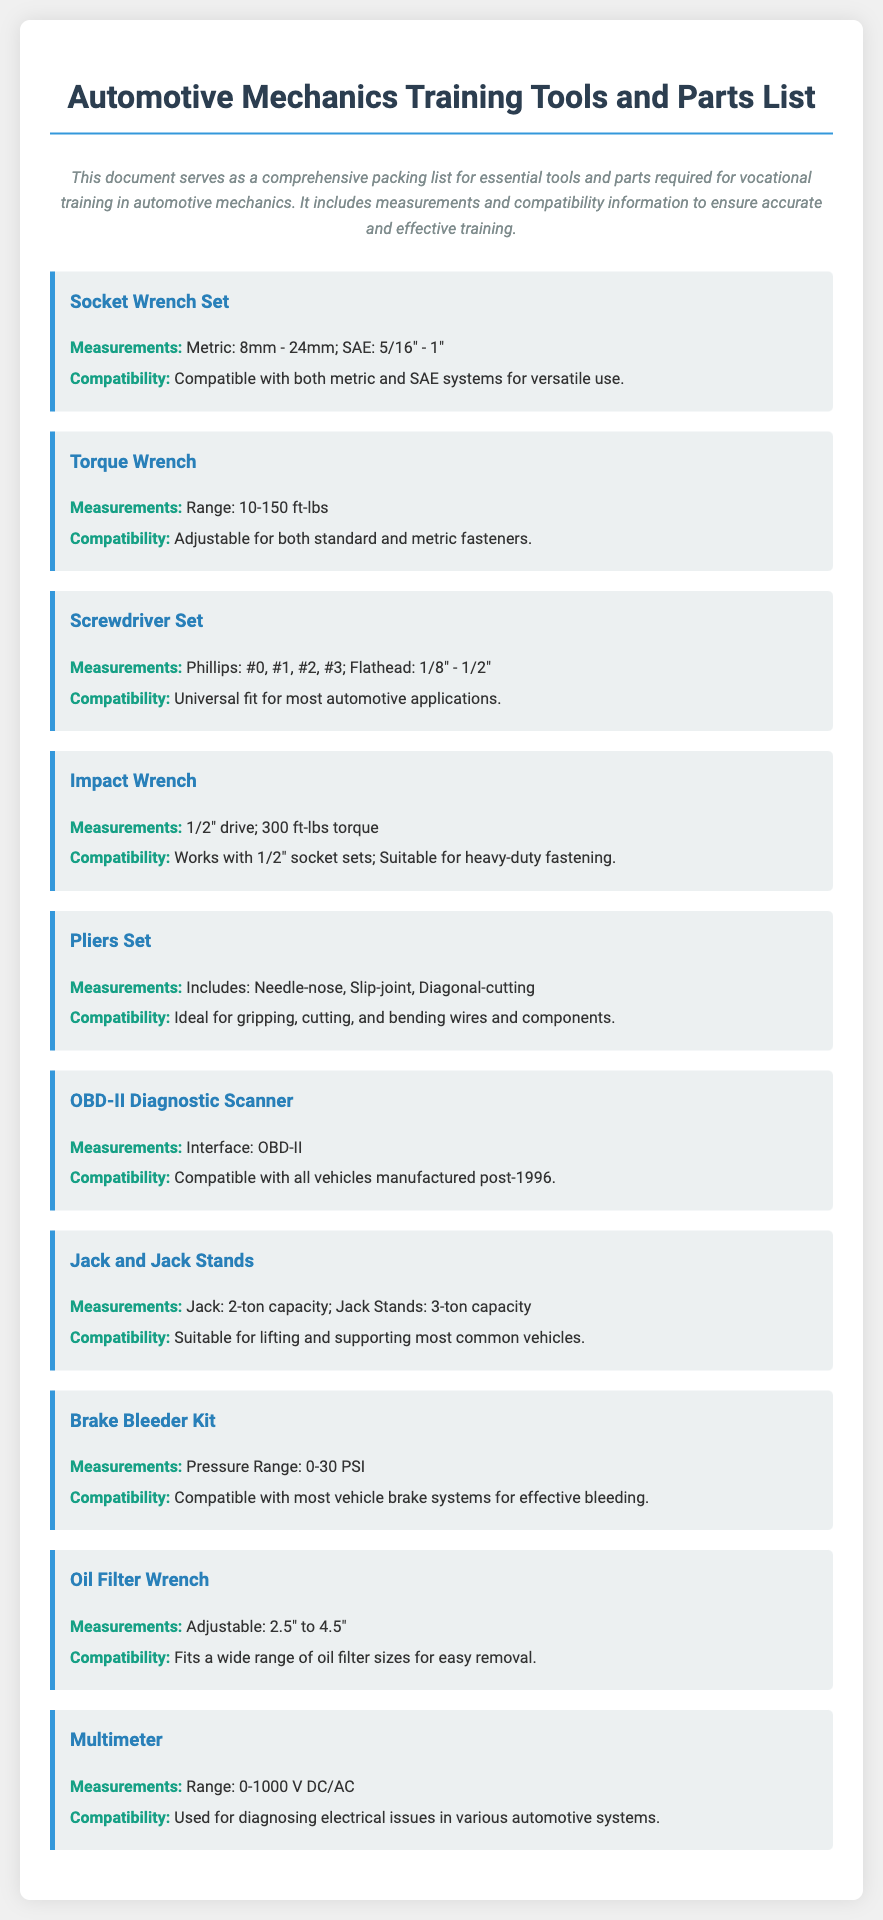What is the measurement range of the Torque Wrench? The measurement range of the Torque Wrench is provided as 10-150 ft-lbs in the document.
Answer: 10-150 ft-lbs What types of screwdrivers are included in the Screwdriver Set? The document specifies that the Screwdriver Set includes Phillips and Flathead types.
Answer: Phillips and Flathead What is the capacity of the Jack mentioned in the document? The Jack's specified capacity is 2-ton in the document.
Answer: 2-ton Which item is compatible with vehicles manufactured post-1996? The document states that the OBD-II Diagnostic Scanner is compatible with all vehicles manufactured post-1996.
Answer: OBD-II Diagnostic Scanner What is the pressure range of the Brake Bleeder Kit? The document indicates that the pressure range of the Brake Bleeder Kit is 0-30 PSI.
Answer: 0-30 PSI What is the adjustable size range of the Oil Filter Wrench? The Oil Filter Wrench's adjustable size range is specified as 2.5" to 4.5" in the document.
Answer: 2.5" to 4.5" How many types of pliers are mentioned in the Pliers Set? The document states that the Pliers Set includes Needle-nose, Slip-joint, and Diagonal-cutting types, indicating three types.
Answer: Three types What type of vehicles can the Multimeter diagnose? The document notes that the Multimeter is used for diagnosing electrical issues in various automotive systems, indicating a variety of vehicles.
Answer: Various automotive systems What is the torque of the Impact Wrench? The specified torque of the Impact Wrench is listed as 300 ft-lbs in the document.
Answer: 300 ft-lbs 